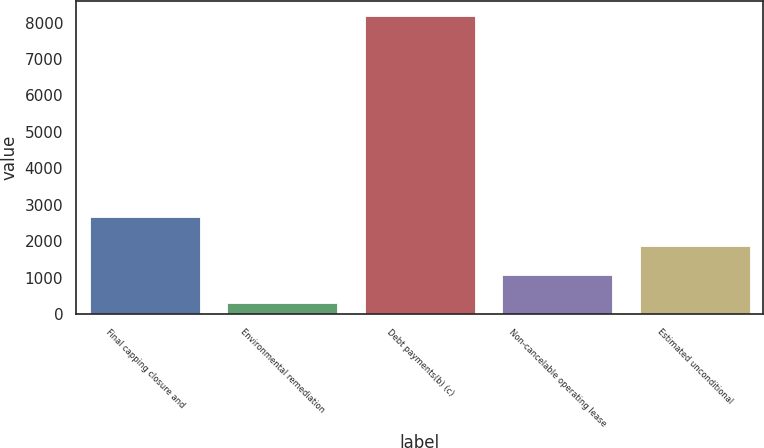<chart> <loc_0><loc_0><loc_500><loc_500><bar_chart><fcel>Final capping closure and<fcel>Environmental remediation<fcel>Debt payments(b) (c)<fcel>Non-cancelable operating lease<fcel>Estimated unconditional<nl><fcel>2661.5<fcel>293<fcel>8188<fcel>1082.5<fcel>1872<nl></chart> 